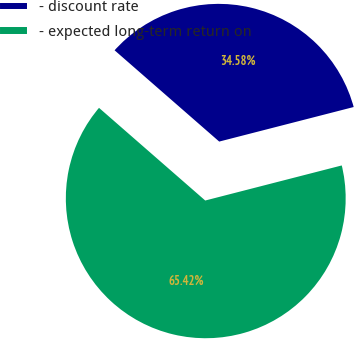<chart> <loc_0><loc_0><loc_500><loc_500><pie_chart><fcel>- discount rate<fcel>- expected long-term return on<nl><fcel>34.58%<fcel>65.42%<nl></chart> 